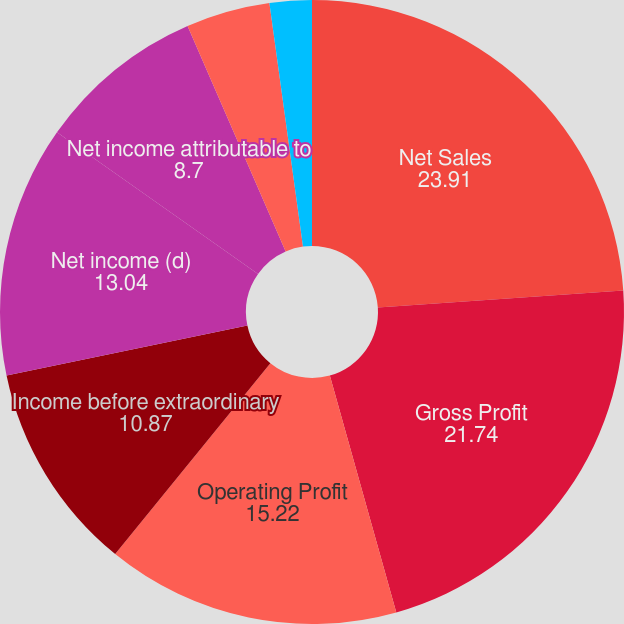<chart> <loc_0><loc_0><loc_500><loc_500><pie_chart><fcel>Net Sales<fcel>Gross Profit<fcel>Operating Profit<fcel>Income before extraordinary<fcel>Net income (d)<fcel>Net income attributable to<fcel>Net income<fcel>Declared<fcel>Paid<nl><fcel>23.91%<fcel>21.74%<fcel>15.22%<fcel>10.87%<fcel>13.04%<fcel>8.7%<fcel>4.35%<fcel>2.18%<fcel>0.0%<nl></chart> 